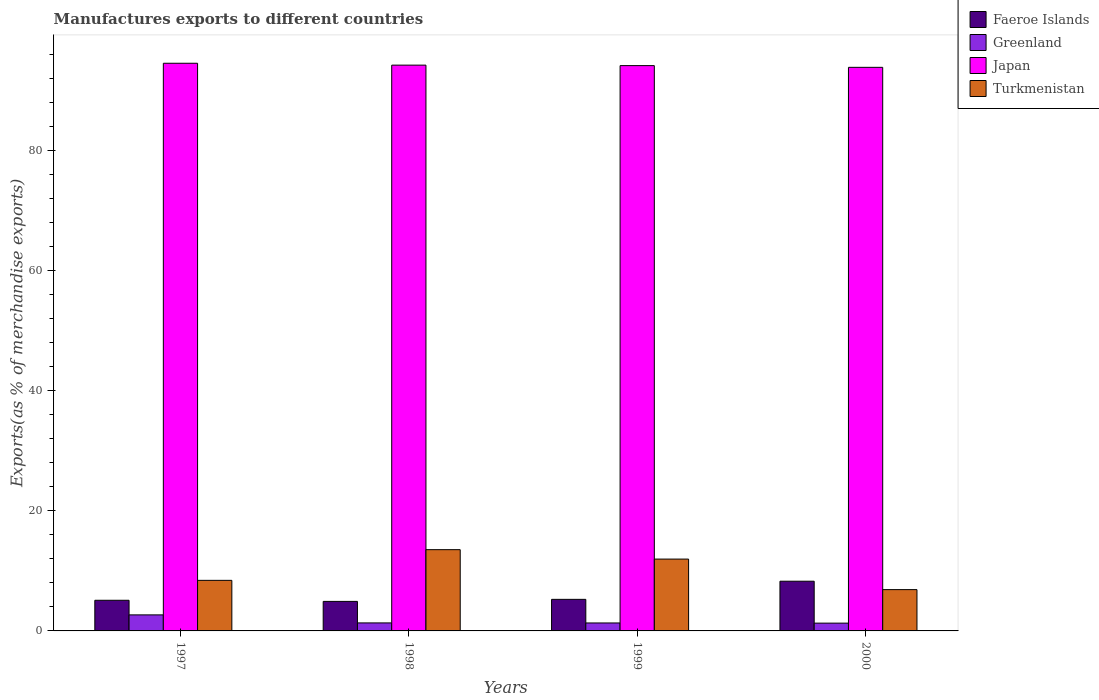How many groups of bars are there?
Ensure brevity in your answer.  4. How many bars are there on the 1st tick from the left?
Ensure brevity in your answer.  4. How many bars are there on the 2nd tick from the right?
Make the answer very short. 4. What is the label of the 4th group of bars from the left?
Offer a terse response. 2000. In how many cases, is the number of bars for a given year not equal to the number of legend labels?
Your answer should be very brief. 0. What is the percentage of exports to different countries in Greenland in 1997?
Ensure brevity in your answer.  2.67. Across all years, what is the maximum percentage of exports to different countries in Greenland?
Ensure brevity in your answer.  2.67. Across all years, what is the minimum percentage of exports to different countries in Turkmenistan?
Make the answer very short. 6.88. In which year was the percentage of exports to different countries in Faeroe Islands maximum?
Your answer should be very brief. 2000. What is the total percentage of exports to different countries in Turkmenistan in the graph?
Your response must be concise. 40.8. What is the difference between the percentage of exports to different countries in Turkmenistan in 1998 and that in 2000?
Offer a terse response. 6.65. What is the difference between the percentage of exports to different countries in Japan in 1998 and the percentage of exports to different countries in Faeroe Islands in 1999?
Keep it short and to the point. 88.99. What is the average percentage of exports to different countries in Greenland per year?
Offer a terse response. 1.66. In the year 1999, what is the difference between the percentage of exports to different countries in Greenland and percentage of exports to different countries in Japan?
Ensure brevity in your answer.  -92.84. What is the ratio of the percentage of exports to different countries in Japan in 1998 to that in 1999?
Your answer should be compact. 1. What is the difference between the highest and the second highest percentage of exports to different countries in Turkmenistan?
Provide a succinct answer. 1.57. What is the difference between the highest and the lowest percentage of exports to different countries in Faeroe Islands?
Your response must be concise. 3.36. Is the sum of the percentage of exports to different countries in Greenland in 1997 and 1998 greater than the maximum percentage of exports to different countries in Faeroe Islands across all years?
Ensure brevity in your answer.  No. Is it the case that in every year, the sum of the percentage of exports to different countries in Japan and percentage of exports to different countries in Turkmenistan is greater than the sum of percentage of exports to different countries in Greenland and percentage of exports to different countries in Faeroe Islands?
Provide a short and direct response. No. What does the 1st bar from the left in 1999 represents?
Offer a very short reply. Faeroe Islands. What does the 3rd bar from the right in 1997 represents?
Provide a short and direct response. Greenland. Is it the case that in every year, the sum of the percentage of exports to different countries in Faeroe Islands and percentage of exports to different countries in Greenland is greater than the percentage of exports to different countries in Japan?
Give a very brief answer. No. What is the difference between two consecutive major ticks on the Y-axis?
Your answer should be very brief. 20. Are the values on the major ticks of Y-axis written in scientific E-notation?
Your answer should be compact. No. Does the graph contain any zero values?
Your answer should be compact. No. Where does the legend appear in the graph?
Make the answer very short. Top right. How many legend labels are there?
Give a very brief answer. 4. What is the title of the graph?
Offer a terse response. Manufactures exports to different countries. What is the label or title of the Y-axis?
Provide a succinct answer. Exports(as % of merchandise exports). What is the Exports(as % of merchandise exports) of Faeroe Islands in 1997?
Your answer should be very brief. 5.1. What is the Exports(as % of merchandise exports) of Greenland in 1997?
Your response must be concise. 2.67. What is the Exports(as % of merchandise exports) in Japan in 1997?
Make the answer very short. 94.56. What is the Exports(as % of merchandise exports) of Turkmenistan in 1997?
Keep it short and to the point. 8.42. What is the Exports(as % of merchandise exports) in Faeroe Islands in 1998?
Provide a short and direct response. 4.92. What is the Exports(as % of merchandise exports) in Greenland in 1998?
Offer a terse response. 1.33. What is the Exports(as % of merchandise exports) of Japan in 1998?
Your response must be concise. 94.24. What is the Exports(as % of merchandise exports) in Turkmenistan in 1998?
Your response must be concise. 13.53. What is the Exports(as % of merchandise exports) in Faeroe Islands in 1999?
Your answer should be compact. 5.26. What is the Exports(as % of merchandise exports) in Greenland in 1999?
Give a very brief answer. 1.33. What is the Exports(as % of merchandise exports) of Japan in 1999?
Your answer should be compact. 94.16. What is the Exports(as % of merchandise exports) in Turkmenistan in 1999?
Offer a very short reply. 11.96. What is the Exports(as % of merchandise exports) in Faeroe Islands in 2000?
Your response must be concise. 8.28. What is the Exports(as % of merchandise exports) of Greenland in 2000?
Offer a very short reply. 1.3. What is the Exports(as % of merchandise exports) of Japan in 2000?
Your answer should be compact. 93.88. What is the Exports(as % of merchandise exports) in Turkmenistan in 2000?
Provide a succinct answer. 6.88. Across all years, what is the maximum Exports(as % of merchandise exports) of Faeroe Islands?
Make the answer very short. 8.28. Across all years, what is the maximum Exports(as % of merchandise exports) of Greenland?
Make the answer very short. 2.67. Across all years, what is the maximum Exports(as % of merchandise exports) of Japan?
Offer a very short reply. 94.56. Across all years, what is the maximum Exports(as % of merchandise exports) of Turkmenistan?
Give a very brief answer. 13.53. Across all years, what is the minimum Exports(as % of merchandise exports) of Faeroe Islands?
Keep it short and to the point. 4.92. Across all years, what is the minimum Exports(as % of merchandise exports) of Greenland?
Make the answer very short. 1.3. Across all years, what is the minimum Exports(as % of merchandise exports) in Japan?
Ensure brevity in your answer.  93.88. Across all years, what is the minimum Exports(as % of merchandise exports) in Turkmenistan?
Make the answer very short. 6.88. What is the total Exports(as % of merchandise exports) of Faeroe Islands in the graph?
Your answer should be very brief. 23.56. What is the total Exports(as % of merchandise exports) of Greenland in the graph?
Keep it short and to the point. 6.63. What is the total Exports(as % of merchandise exports) of Japan in the graph?
Offer a terse response. 376.84. What is the total Exports(as % of merchandise exports) of Turkmenistan in the graph?
Offer a very short reply. 40.8. What is the difference between the Exports(as % of merchandise exports) of Faeroe Islands in 1997 and that in 1998?
Your answer should be very brief. 0.19. What is the difference between the Exports(as % of merchandise exports) in Greenland in 1997 and that in 1998?
Offer a terse response. 1.34. What is the difference between the Exports(as % of merchandise exports) in Japan in 1997 and that in 1998?
Your answer should be very brief. 0.31. What is the difference between the Exports(as % of merchandise exports) of Turkmenistan in 1997 and that in 1998?
Give a very brief answer. -5.11. What is the difference between the Exports(as % of merchandise exports) in Faeroe Islands in 1997 and that in 1999?
Provide a succinct answer. -0.16. What is the difference between the Exports(as % of merchandise exports) of Greenland in 1997 and that in 1999?
Your response must be concise. 1.35. What is the difference between the Exports(as % of merchandise exports) of Japan in 1997 and that in 1999?
Your answer should be very brief. 0.39. What is the difference between the Exports(as % of merchandise exports) of Turkmenistan in 1997 and that in 1999?
Give a very brief answer. -3.54. What is the difference between the Exports(as % of merchandise exports) in Faeroe Islands in 1997 and that in 2000?
Your response must be concise. -3.18. What is the difference between the Exports(as % of merchandise exports) in Greenland in 1997 and that in 2000?
Your response must be concise. 1.37. What is the difference between the Exports(as % of merchandise exports) of Japan in 1997 and that in 2000?
Ensure brevity in your answer.  0.68. What is the difference between the Exports(as % of merchandise exports) of Turkmenistan in 1997 and that in 2000?
Give a very brief answer. 1.54. What is the difference between the Exports(as % of merchandise exports) in Faeroe Islands in 1998 and that in 1999?
Provide a short and direct response. -0.34. What is the difference between the Exports(as % of merchandise exports) of Greenland in 1998 and that in 1999?
Ensure brevity in your answer.  0.01. What is the difference between the Exports(as % of merchandise exports) of Japan in 1998 and that in 1999?
Provide a short and direct response. 0.08. What is the difference between the Exports(as % of merchandise exports) in Turkmenistan in 1998 and that in 1999?
Provide a succinct answer. 1.57. What is the difference between the Exports(as % of merchandise exports) in Faeroe Islands in 1998 and that in 2000?
Make the answer very short. -3.36. What is the difference between the Exports(as % of merchandise exports) in Greenland in 1998 and that in 2000?
Your answer should be compact. 0.04. What is the difference between the Exports(as % of merchandise exports) of Japan in 1998 and that in 2000?
Provide a succinct answer. 0.37. What is the difference between the Exports(as % of merchandise exports) in Turkmenistan in 1998 and that in 2000?
Your answer should be very brief. 6.65. What is the difference between the Exports(as % of merchandise exports) in Faeroe Islands in 1999 and that in 2000?
Make the answer very short. -3.02. What is the difference between the Exports(as % of merchandise exports) of Greenland in 1999 and that in 2000?
Provide a succinct answer. 0.03. What is the difference between the Exports(as % of merchandise exports) of Japan in 1999 and that in 2000?
Your answer should be very brief. 0.29. What is the difference between the Exports(as % of merchandise exports) in Turkmenistan in 1999 and that in 2000?
Your answer should be very brief. 5.08. What is the difference between the Exports(as % of merchandise exports) in Faeroe Islands in 1997 and the Exports(as % of merchandise exports) in Greenland in 1998?
Provide a short and direct response. 3.77. What is the difference between the Exports(as % of merchandise exports) in Faeroe Islands in 1997 and the Exports(as % of merchandise exports) in Japan in 1998?
Ensure brevity in your answer.  -89.14. What is the difference between the Exports(as % of merchandise exports) in Faeroe Islands in 1997 and the Exports(as % of merchandise exports) in Turkmenistan in 1998?
Keep it short and to the point. -8.43. What is the difference between the Exports(as % of merchandise exports) of Greenland in 1997 and the Exports(as % of merchandise exports) of Japan in 1998?
Provide a short and direct response. -91.57. What is the difference between the Exports(as % of merchandise exports) of Greenland in 1997 and the Exports(as % of merchandise exports) of Turkmenistan in 1998?
Your answer should be very brief. -10.86. What is the difference between the Exports(as % of merchandise exports) of Japan in 1997 and the Exports(as % of merchandise exports) of Turkmenistan in 1998?
Ensure brevity in your answer.  81.02. What is the difference between the Exports(as % of merchandise exports) of Faeroe Islands in 1997 and the Exports(as % of merchandise exports) of Greenland in 1999?
Your answer should be very brief. 3.78. What is the difference between the Exports(as % of merchandise exports) of Faeroe Islands in 1997 and the Exports(as % of merchandise exports) of Japan in 1999?
Ensure brevity in your answer.  -89.06. What is the difference between the Exports(as % of merchandise exports) of Faeroe Islands in 1997 and the Exports(as % of merchandise exports) of Turkmenistan in 1999?
Provide a short and direct response. -6.86. What is the difference between the Exports(as % of merchandise exports) of Greenland in 1997 and the Exports(as % of merchandise exports) of Japan in 1999?
Your response must be concise. -91.49. What is the difference between the Exports(as % of merchandise exports) in Greenland in 1997 and the Exports(as % of merchandise exports) in Turkmenistan in 1999?
Provide a succinct answer. -9.29. What is the difference between the Exports(as % of merchandise exports) of Japan in 1997 and the Exports(as % of merchandise exports) of Turkmenistan in 1999?
Your response must be concise. 82.59. What is the difference between the Exports(as % of merchandise exports) in Faeroe Islands in 1997 and the Exports(as % of merchandise exports) in Greenland in 2000?
Your response must be concise. 3.81. What is the difference between the Exports(as % of merchandise exports) of Faeroe Islands in 1997 and the Exports(as % of merchandise exports) of Japan in 2000?
Provide a succinct answer. -88.77. What is the difference between the Exports(as % of merchandise exports) of Faeroe Islands in 1997 and the Exports(as % of merchandise exports) of Turkmenistan in 2000?
Give a very brief answer. -1.78. What is the difference between the Exports(as % of merchandise exports) of Greenland in 1997 and the Exports(as % of merchandise exports) of Japan in 2000?
Offer a terse response. -91.21. What is the difference between the Exports(as % of merchandise exports) of Greenland in 1997 and the Exports(as % of merchandise exports) of Turkmenistan in 2000?
Make the answer very short. -4.21. What is the difference between the Exports(as % of merchandise exports) in Japan in 1997 and the Exports(as % of merchandise exports) in Turkmenistan in 2000?
Your response must be concise. 87.68. What is the difference between the Exports(as % of merchandise exports) in Faeroe Islands in 1998 and the Exports(as % of merchandise exports) in Greenland in 1999?
Offer a terse response. 3.59. What is the difference between the Exports(as % of merchandise exports) in Faeroe Islands in 1998 and the Exports(as % of merchandise exports) in Japan in 1999?
Give a very brief answer. -89.25. What is the difference between the Exports(as % of merchandise exports) of Faeroe Islands in 1998 and the Exports(as % of merchandise exports) of Turkmenistan in 1999?
Provide a short and direct response. -7.05. What is the difference between the Exports(as % of merchandise exports) of Greenland in 1998 and the Exports(as % of merchandise exports) of Japan in 1999?
Provide a succinct answer. -92.83. What is the difference between the Exports(as % of merchandise exports) in Greenland in 1998 and the Exports(as % of merchandise exports) in Turkmenistan in 1999?
Provide a succinct answer. -10.63. What is the difference between the Exports(as % of merchandise exports) in Japan in 1998 and the Exports(as % of merchandise exports) in Turkmenistan in 1999?
Offer a terse response. 82.28. What is the difference between the Exports(as % of merchandise exports) of Faeroe Islands in 1998 and the Exports(as % of merchandise exports) of Greenland in 2000?
Offer a terse response. 3.62. What is the difference between the Exports(as % of merchandise exports) in Faeroe Islands in 1998 and the Exports(as % of merchandise exports) in Japan in 2000?
Make the answer very short. -88.96. What is the difference between the Exports(as % of merchandise exports) in Faeroe Islands in 1998 and the Exports(as % of merchandise exports) in Turkmenistan in 2000?
Your answer should be very brief. -1.96. What is the difference between the Exports(as % of merchandise exports) in Greenland in 1998 and the Exports(as % of merchandise exports) in Japan in 2000?
Offer a terse response. -92.54. What is the difference between the Exports(as % of merchandise exports) of Greenland in 1998 and the Exports(as % of merchandise exports) of Turkmenistan in 2000?
Your response must be concise. -5.55. What is the difference between the Exports(as % of merchandise exports) of Japan in 1998 and the Exports(as % of merchandise exports) of Turkmenistan in 2000?
Provide a succinct answer. 87.36. What is the difference between the Exports(as % of merchandise exports) of Faeroe Islands in 1999 and the Exports(as % of merchandise exports) of Greenland in 2000?
Your response must be concise. 3.96. What is the difference between the Exports(as % of merchandise exports) of Faeroe Islands in 1999 and the Exports(as % of merchandise exports) of Japan in 2000?
Keep it short and to the point. -88.62. What is the difference between the Exports(as % of merchandise exports) of Faeroe Islands in 1999 and the Exports(as % of merchandise exports) of Turkmenistan in 2000?
Provide a short and direct response. -1.62. What is the difference between the Exports(as % of merchandise exports) in Greenland in 1999 and the Exports(as % of merchandise exports) in Japan in 2000?
Give a very brief answer. -92.55. What is the difference between the Exports(as % of merchandise exports) of Greenland in 1999 and the Exports(as % of merchandise exports) of Turkmenistan in 2000?
Offer a terse response. -5.56. What is the difference between the Exports(as % of merchandise exports) in Japan in 1999 and the Exports(as % of merchandise exports) in Turkmenistan in 2000?
Provide a succinct answer. 87.28. What is the average Exports(as % of merchandise exports) in Faeroe Islands per year?
Your answer should be compact. 5.89. What is the average Exports(as % of merchandise exports) of Greenland per year?
Ensure brevity in your answer.  1.66. What is the average Exports(as % of merchandise exports) in Japan per year?
Ensure brevity in your answer.  94.21. What is the average Exports(as % of merchandise exports) in Turkmenistan per year?
Your answer should be compact. 10.2. In the year 1997, what is the difference between the Exports(as % of merchandise exports) in Faeroe Islands and Exports(as % of merchandise exports) in Greenland?
Keep it short and to the point. 2.43. In the year 1997, what is the difference between the Exports(as % of merchandise exports) in Faeroe Islands and Exports(as % of merchandise exports) in Japan?
Provide a short and direct response. -89.45. In the year 1997, what is the difference between the Exports(as % of merchandise exports) of Faeroe Islands and Exports(as % of merchandise exports) of Turkmenistan?
Offer a very short reply. -3.32. In the year 1997, what is the difference between the Exports(as % of merchandise exports) of Greenland and Exports(as % of merchandise exports) of Japan?
Provide a succinct answer. -91.89. In the year 1997, what is the difference between the Exports(as % of merchandise exports) of Greenland and Exports(as % of merchandise exports) of Turkmenistan?
Provide a short and direct response. -5.75. In the year 1997, what is the difference between the Exports(as % of merchandise exports) of Japan and Exports(as % of merchandise exports) of Turkmenistan?
Make the answer very short. 86.13. In the year 1998, what is the difference between the Exports(as % of merchandise exports) in Faeroe Islands and Exports(as % of merchandise exports) in Greenland?
Make the answer very short. 3.58. In the year 1998, what is the difference between the Exports(as % of merchandise exports) in Faeroe Islands and Exports(as % of merchandise exports) in Japan?
Ensure brevity in your answer.  -89.33. In the year 1998, what is the difference between the Exports(as % of merchandise exports) of Faeroe Islands and Exports(as % of merchandise exports) of Turkmenistan?
Your answer should be very brief. -8.62. In the year 1998, what is the difference between the Exports(as % of merchandise exports) in Greenland and Exports(as % of merchandise exports) in Japan?
Your answer should be very brief. -92.91. In the year 1998, what is the difference between the Exports(as % of merchandise exports) of Greenland and Exports(as % of merchandise exports) of Turkmenistan?
Provide a short and direct response. -12.2. In the year 1998, what is the difference between the Exports(as % of merchandise exports) of Japan and Exports(as % of merchandise exports) of Turkmenistan?
Provide a short and direct response. 80.71. In the year 1999, what is the difference between the Exports(as % of merchandise exports) in Faeroe Islands and Exports(as % of merchandise exports) in Greenland?
Keep it short and to the point. 3.93. In the year 1999, what is the difference between the Exports(as % of merchandise exports) in Faeroe Islands and Exports(as % of merchandise exports) in Japan?
Keep it short and to the point. -88.9. In the year 1999, what is the difference between the Exports(as % of merchandise exports) in Faeroe Islands and Exports(as % of merchandise exports) in Turkmenistan?
Offer a very short reply. -6.71. In the year 1999, what is the difference between the Exports(as % of merchandise exports) in Greenland and Exports(as % of merchandise exports) in Japan?
Offer a very short reply. -92.84. In the year 1999, what is the difference between the Exports(as % of merchandise exports) in Greenland and Exports(as % of merchandise exports) in Turkmenistan?
Your answer should be compact. -10.64. In the year 1999, what is the difference between the Exports(as % of merchandise exports) in Japan and Exports(as % of merchandise exports) in Turkmenistan?
Keep it short and to the point. 82.2. In the year 2000, what is the difference between the Exports(as % of merchandise exports) in Faeroe Islands and Exports(as % of merchandise exports) in Greenland?
Offer a terse response. 6.98. In the year 2000, what is the difference between the Exports(as % of merchandise exports) in Faeroe Islands and Exports(as % of merchandise exports) in Japan?
Offer a terse response. -85.6. In the year 2000, what is the difference between the Exports(as % of merchandise exports) of Faeroe Islands and Exports(as % of merchandise exports) of Turkmenistan?
Offer a terse response. 1.4. In the year 2000, what is the difference between the Exports(as % of merchandise exports) of Greenland and Exports(as % of merchandise exports) of Japan?
Keep it short and to the point. -92.58. In the year 2000, what is the difference between the Exports(as % of merchandise exports) in Greenland and Exports(as % of merchandise exports) in Turkmenistan?
Make the answer very short. -5.58. In the year 2000, what is the difference between the Exports(as % of merchandise exports) in Japan and Exports(as % of merchandise exports) in Turkmenistan?
Give a very brief answer. 87. What is the ratio of the Exports(as % of merchandise exports) in Faeroe Islands in 1997 to that in 1998?
Provide a short and direct response. 1.04. What is the ratio of the Exports(as % of merchandise exports) in Greenland in 1997 to that in 1998?
Make the answer very short. 2. What is the ratio of the Exports(as % of merchandise exports) of Japan in 1997 to that in 1998?
Provide a short and direct response. 1. What is the ratio of the Exports(as % of merchandise exports) of Turkmenistan in 1997 to that in 1998?
Your response must be concise. 0.62. What is the ratio of the Exports(as % of merchandise exports) in Faeroe Islands in 1997 to that in 1999?
Your response must be concise. 0.97. What is the ratio of the Exports(as % of merchandise exports) of Greenland in 1997 to that in 1999?
Offer a very short reply. 2.02. What is the ratio of the Exports(as % of merchandise exports) of Japan in 1997 to that in 1999?
Make the answer very short. 1. What is the ratio of the Exports(as % of merchandise exports) in Turkmenistan in 1997 to that in 1999?
Your response must be concise. 0.7. What is the ratio of the Exports(as % of merchandise exports) of Faeroe Islands in 1997 to that in 2000?
Your answer should be very brief. 0.62. What is the ratio of the Exports(as % of merchandise exports) in Greenland in 1997 to that in 2000?
Offer a very short reply. 2.06. What is the ratio of the Exports(as % of merchandise exports) in Japan in 1997 to that in 2000?
Your answer should be compact. 1.01. What is the ratio of the Exports(as % of merchandise exports) of Turkmenistan in 1997 to that in 2000?
Ensure brevity in your answer.  1.22. What is the ratio of the Exports(as % of merchandise exports) of Faeroe Islands in 1998 to that in 1999?
Offer a terse response. 0.94. What is the ratio of the Exports(as % of merchandise exports) in Japan in 1998 to that in 1999?
Your answer should be compact. 1. What is the ratio of the Exports(as % of merchandise exports) of Turkmenistan in 1998 to that in 1999?
Make the answer very short. 1.13. What is the ratio of the Exports(as % of merchandise exports) of Faeroe Islands in 1998 to that in 2000?
Your response must be concise. 0.59. What is the ratio of the Exports(as % of merchandise exports) of Japan in 1998 to that in 2000?
Offer a very short reply. 1. What is the ratio of the Exports(as % of merchandise exports) in Turkmenistan in 1998 to that in 2000?
Keep it short and to the point. 1.97. What is the ratio of the Exports(as % of merchandise exports) in Faeroe Islands in 1999 to that in 2000?
Your answer should be very brief. 0.64. What is the ratio of the Exports(as % of merchandise exports) of Greenland in 1999 to that in 2000?
Your response must be concise. 1.02. What is the ratio of the Exports(as % of merchandise exports) in Japan in 1999 to that in 2000?
Ensure brevity in your answer.  1. What is the ratio of the Exports(as % of merchandise exports) in Turkmenistan in 1999 to that in 2000?
Give a very brief answer. 1.74. What is the difference between the highest and the second highest Exports(as % of merchandise exports) in Faeroe Islands?
Keep it short and to the point. 3.02. What is the difference between the highest and the second highest Exports(as % of merchandise exports) of Greenland?
Your answer should be compact. 1.34. What is the difference between the highest and the second highest Exports(as % of merchandise exports) of Japan?
Provide a succinct answer. 0.31. What is the difference between the highest and the second highest Exports(as % of merchandise exports) in Turkmenistan?
Your answer should be compact. 1.57. What is the difference between the highest and the lowest Exports(as % of merchandise exports) of Faeroe Islands?
Offer a very short reply. 3.36. What is the difference between the highest and the lowest Exports(as % of merchandise exports) of Greenland?
Your answer should be compact. 1.37. What is the difference between the highest and the lowest Exports(as % of merchandise exports) of Japan?
Ensure brevity in your answer.  0.68. What is the difference between the highest and the lowest Exports(as % of merchandise exports) in Turkmenistan?
Your answer should be very brief. 6.65. 